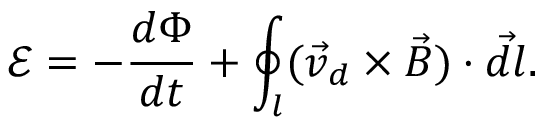<formula> <loc_0><loc_0><loc_500><loc_500>\mathcal { E } = - \frac { d \Phi } { d t } + \oint _ { l } ( \vec { v } _ { d } \times \vec { B } ) \cdot \vec { d l } .</formula> 